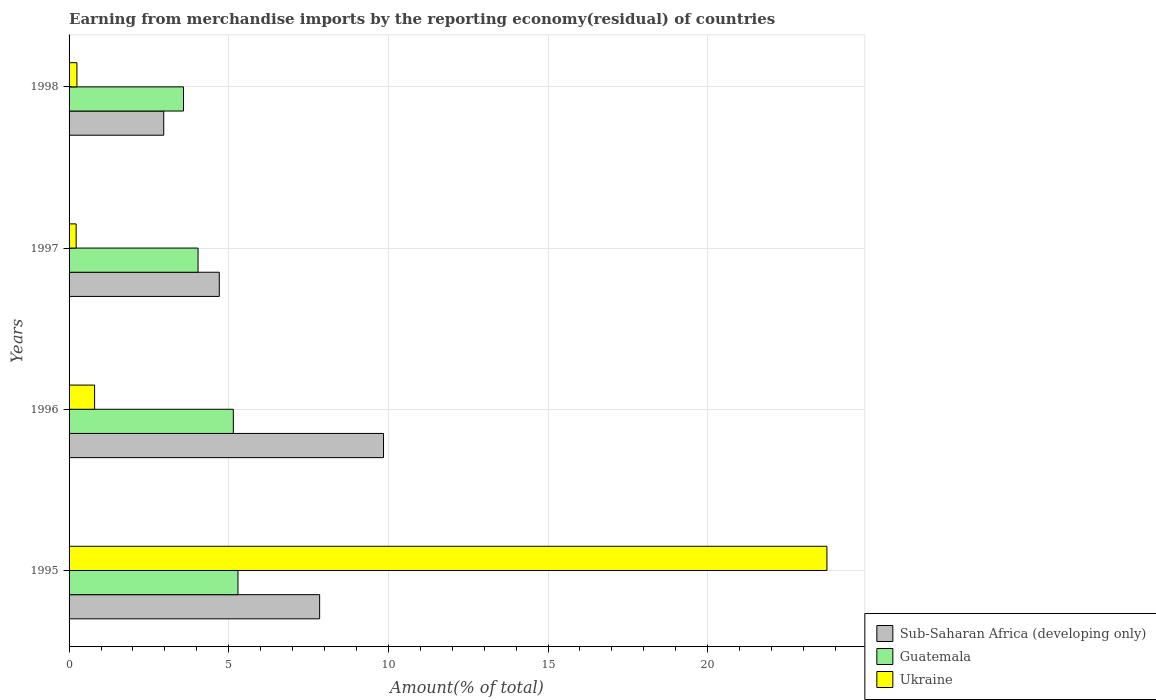How many different coloured bars are there?
Provide a succinct answer. 3. How many groups of bars are there?
Offer a very short reply. 4. How many bars are there on the 3rd tick from the top?
Your answer should be compact. 3. What is the label of the 3rd group of bars from the top?
Your answer should be compact. 1996. In how many cases, is the number of bars for a given year not equal to the number of legend labels?
Provide a succinct answer. 0. What is the percentage of amount earned from merchandise imports in Guatemala in 1995?
Your answer should be compact. 5.29. Across all years, what is the maximum percentage of amount earned from merchandise imports in Guatemala?
Your answer should be very brief. 5.29. Across all years, what is the minimum percentage of amount earned from merchandise imports in Ukraine?
Your response must be concise. 0.22. In which year was the percentage of amount earned from merchandise imports in Sub-Saharan Africa (developing only) maximum?
Offer a terse response. 1996. In which year was the percentage of amount earned from merchandise imports in Sub-Saharan Africa (developing only) minimum?
Offer a terse response. 1998. What is the total percentage of amount earned from merchandise imports in Ukraine in the graph?
Offer a terse response. 25. What is the difference between the percentage of amount earned from merchandise imports in Ukraine in 1996 and that in 1997?
Offer a very short reply. 0.58. What is the difference between the percentage of amount earned from merchandise imports in Sub-Saharan Africa (developing only) in 1996 and the percentage of amount earned from merchandise imports in Ukraine in 1995?
Your response must be concise. -13.89. What is the average percentage of amount earned from merchandise imports in Sub-Saharan Africa (developing only) per year?
Ensure brevity in your answer.  6.34. In the year 1995, what is the difference between the percentage of amount earned from merchandise imports in Ukraine and percentage of amount earned from merchandise imports in Guatemala?
Ensure brevity in your answer.  18.45. What is the ratio of the percentage of amount earned from merchandise imports in Guatemala in 1995 to that in 1996?
Your answer should be very brief. 1.03. Is the difference between the percentage of amount earned from merchandise imports in Ukraine in 1996 and 1998 greater than the difference between the percentage of amount earned from merchandise imports in Guatemala in 1996 and 1998?
Provide a short and direct response. No. What is the difference between the highest and the second highest percentage of amount earned from merchandise imports in Sub-Saharan Africa (developing only)?
Offer a very short reply. 2. What is the difference between the highest and the lowest percentage of amount earned from merchandise imports in Guatemala?
Ensure brevity in your answer.  1.71. In how many years, is the percentage of amount earned from merchandise imports in Sub-Saharan Africa (developing only) greater than the average percentage of amount earned from merchandise imports in Sub-Saharan Africa (developing only) taken over all years?
Offer a very short reply. 2. What does the 2nd bar from the top in 1997 represents?
Provide a succinct answer. Guatemala. What does the 1st bar from the bottom in 1996 represents?
Make the answer very short. Sub-Saharan Africa (developing only). How many bars are there?
Your answer should be compact. 12. Are the values on the major ticks of X-axis written in scientific E-notation?
Your response must be concise. No. How many legend labels are there?
Ensure brevity in your answer.  3. How are the legend labels stacked?
Offer a very short reply. Vertical. What is the title of the graph?
Keep it short and to the point. Earning from merchandise imports by the reporting economy(residual) of countries. What is the label or title of the X-axis?
Provide a short and direct response. Amount(% of total). What is the label or title of the Y-axis?
Provide a short and direct response. Years. What is the Amount(% of total) in Sub-Saharan Africa (developing only) in 1995?
Ensure brevity in your answer.  7.85. What is the Amount(% of total) in Guatemala in 1995?
Your answer should be very brief. 5.29. What is the Amount(% of total) of Ukraine in 1995?
Ensure brevity in your answer.  23.74. What is the Amount(% of total) of Sub-Saharan Africa (developing only) in 1996?
Your answer should be compact. 9.85. What is the Amount(% of total) in Guatemala in 1996?
Your answer should be very brief. 5.14. What is the Amount(% of total) in Ukraine in 1996?
Provide a succinct answer. 0.8. What is the Amount(% of total) of Sub-Saharan Africa (developing only) in 1997?
Provide a succinct answer. 4.7. What is the Amount(% of total) of Guatemala in 1997?
Your answer should be very brief. 4.04. What is the Amount(% of total) of Ukraine in 1997?
Provide a succinct answer. 0.22. What is the Amount(% of total) in Sub-Saharan Africa (developing only) in 1998?
Ensure brevity in your answer.  2.96. What is the Amount(% of total) of Guatemala in 1998?
Give a very brief answer. 3.58. What is the Amount(% of total) in Ukraine in 1998?
Offer a terse response. 0.25. Across all years, what is the maximum Amount(% of total) of Sub-Saharan Africa (developing only)?
Your answer should be compact. 9.85. Across all years, what is the maximum Amount(% of total) of Guatemala?
Provide a succinct answer. 5.29. Across all years, what is the maximum Amount(% of total) of Ukraine?
Offer a terse response. 23.74. Across all years, what is the minimum Amount(% of total) of Sub-Saharan Africa (developing only)?
Offer a terse response. 2.96. Across all years, what is the minimum Amount(% of total) in Guatemala?
Keep it short and to the point. 3.58. Across all years, what is the minimum Amount(% of total) in Ukraine?
Your response must be concise. 0.22. What is the total Amount(% of total) of Sub-Saharan Africa (developing only) in the graph?
Give a very brief answer. 25.37. What is the total Amount(% of total) of Guatemala in the graph?
Offer a very short reply. 18.06. What is the total Amount(% of total) of Ukraine in the graph?
Your response must be concise. 25. What is the difference between the Amount(% of total) of Sub-Saharan Africa (developing only) in 1995 and that in 1996?
Offer a terse response. -2. What is the difference between the Amount(% of total) of Guatemala in 1995 and that in 1996?
Keep it short and to the point. 0.15. What is the difference between the Amount(% of total) in Ukraine in 1995 and that in 1996?
Your answer should be compact. 22.94. What is the difference between the Amount(% of total) of Sub-Saharan Africa (developing only) in 1995 and that in 1997?
Your answer should be very brief. 3.14. What is the difference between the Amount(% of total) of Guatemala in 1995 and that in 1997?
Offer a very short reply. 1.25. What is the difference between the Amount(% of total) of Ukraine in 1995 and that in 1997?
Offer a very short reply. 23.51. What is the difference between the Amount(% of total) of Sub-Saharan Africa (developing only) in 1995 and that in 1998?
Offer a very short reply. 4.88. What is the difference between the Amount(% of total) in Guatemala in 1995 and that in 1998?
Your answer should be very brief. 1.71. What is the difference between the Amount(% of total) in Ukraine in 1995 and that in 1998?
Provide a succinct answer. 23.49. What is the difference between the Amount(% of total) in Sub-Saharan Africa (developing only) in 1996 and that in 1997?
Ensure brevity in your answer.  5.14. What is the difference between the Amount(% of total) in Guatemala in 1996 and that in 1997?
Provide a short and direct response. 1.1. What is the difference between the Amount(% of total) in Ukraine in 1996 and that in 1997?
Your response must be concise. 0.58. What is the difference between the Amount(% of total) in Sub-Saharan Africa (developing only) in 1996 and that in 1998?
Offer a very short reply. 6.88. What is the difference between the Amount(% of total) of Guatemala in 1996 and that in 1998?
Make the answer very short. 1.56. What is the difference between the Amount(% of total) of Ukraine in 1996 and that in 1998?
Make the answer very short. 0.55. What is the difference between the Amount(% of total) of Sub-Saharan Africa (developing only) in 1997 and that in 1998?
Give a very brief answer. 1.74. What is the difference between the Amount(% of total) of Guatemala in 1997 and that in 1998?
Give a very brief answer. 0.46. What is the difference between the Amount(% of total) of Ukraine in 1997 and that in 1998?
Ensure brevity in your answer.  -0.02. What is the difference between the Amount(% of total) in Sub-Saharan Africa (developing only) in 1995 and the Amount(% of total) in Guatemala in 1996?
Keep it short and to the point. 2.7. What is the difference between the Amount(% of total) in Sub-Saharan Africa (developing only) in 1995 and the Amount(% of total) in Ukraine in 1996?
Provide a succinct answer. 7.05. What is the difference between the Amount(% of total) of Guatemala in 1995 and the Amount(% of total) of Ukraine in 1996?
Offer a terse response. 4.49. What is the difference between the Amount(% of total) in Sub-Saharan Africa (developing only) in 1995 and the Amount(% of total) in Guatemala in 1997?
Your response must be concise. 3.81. What is the difference between the Amount(% of total) of Sub-Saharan Africa (developing only) in 1995 and the Amount(% of total) of Ukraine in 1997?
Your answer should be compact. 7.63. What is the difference between the Amount(% of total) of Guatemala in 1995 and the Amount(% of total) of Ukraine in 1997?
Make the answer very short. 5.07. What is the difference between the Amount(% of total) in Sub-Saharan Africa (developing only) in 1995 and the Amount(% of total) in Guatemala in 1998?
Give a very brief answer. 4.26. What is the difference between the Amount(% of total) in Sub-Saharan Africa (developing only) in 1995 and the Amount(% of total) in Ukraine in 1998?
Provide a succinct answer. 7.6. What is the difference between the Amount(% of total) of Guatemala in 1995 and the Amount(% of total) of Ukraine in 1998?
Provide a short and direct response. 5.04. What is the difference between the Amount(% of total) in Sub-Saharan Africa (developing only) in 1996 and the Amount(% of total) in Guatemala in 1997?
Make the answer very short. 5.81. What is the difference between the Amount(% of total) in Sub-Saharan Africa (developing only) in 1996 and the Amount(% of total) in Ukraine in 1997?
Offer a very short reply. 9.63. What is the difference between the Amount(% of total) in Guatemala in 1996 and the Amount(% of total) in Ukraine in 1997?
Provide a succinct answer. 4.92. What is the difference between the Amount(% of total) of Sub-Saharan Africa (developing only) in 1996 and the Amount(% of total) of Guatemala in 1998?
Offer a terse response. 6.26. What is the difference between the Amount(% of total) in Sub-Saharan Africa (developing only) in 1996 and the Amount(% of total) in Ukraine in 1998?
Give a very brief answer. 9.6. What is the difference between the Amount(% of total) of Guatemala in 1996 and the Amount(% of total) of Ukraine in 1998?
Provide a succinct answer. 4.9. What is the difference between the Amount(% of total) in Sub-Saharan Africa (developing only) in 1997 and the Amount(% of total) in Guatemala in 1998?
Offer a terse response. 1.12. What is the difference between the Amount(% of total) of Sub-Saharan Africa (developing only) in 1997 and the Amount(% of total) of Ukraine in 1998?
Provide a short and direct response. 4.46. What is the difference between the Amount(% of total) of Guatemala in 1997 and the Amount(% of total) of Ukraine in 1998?
Offer a terse response. 3.79. What is the average Amount(% of total) in Sub-Saharan Africa (developing only) per year?
Ensure brevity in your answer.  6.34. What is the average Amount(% of total) of Guatemala per year?
Give a very brief answer. 4.51. What is the average Amount(% of total) of Ukraine per year?
Ensure brevity in your answer.  6.25. In the year 1995, what is the difference between the Amount(% of total) of Sub-Saharan Africa (developing only) and Amount(% of total) of Guatemala?
Offer a very short reply. 2.56. In the year 1995, what is the difference between the Amount(% of total) in Sub-Saharan Africa (developing only) and Amount(% of total) in Ukraine?
Provide a short and direct response. -15.89. In the year 1995, what is the difference between the Amount(% of total) of Guatemala and Amount(% of total) of Ukraine?
Your response must be concise. -18.45. In the year 1996, what is the difference between the Amount(% of total) of Sub-Saharan Africa (developing only) and Amount(% of total) of Guatemala?
Provide a short and direct response. 4.7. In the year 1996, what is the difference between the Amount(% of total) of Sub-Saharan Africa (developing only) and Amount(% of total) of Ukraine?
Your response must be concise. 9.05. In the year 1996, what is the difference between the Amount(% of total) of Guatemala and Amount(% of total) of Ukraine?
Provide a succinct answer. 4.34. In the year 1997, what is the difference between the Amount(% of total) in Sub-Saharan Africa (developing only) and Amount(% of total) in Guatemala?
Provide a succinct answer. 0.66. In the year 1997, what is the difference between the Amount(% of total) in Sub-Saharan Africa (developing only) and Amount(% of total) in Ukraine?
Keep it short and to the point. 4.48. In the year 1997, what is the difference between the Amount(% of total) of Guatemala and Amount(% of total) of Ukraine?
Offer a very short reply. 3.82. In the year 1998, what is the difference between the Amount(% of total) in Sub-Saharan Africa (developing only) and Amount(% of total) in Guatemala?
Make the answer very short. -0.62. In the year 1998, what is the difference between the Amount(% of total) of Sub-Saharan Africa (developing only) and Amount(% of total) of Ukraine?
Your answer should be compact. 2.72. In the year 1998, what is the difference between the Amount(% of total) of Guatemala and Amount(% of total) of Ukraine?
Your answer should be compact. 3.34. What is the ratio of the Amount(% of total) of Sub-Saharan Africa (developing only) in 1995 to that in 1996?
Make the answer very short. 0.8. What is the ratio of the Amount(% of total) in Guatemala in 1995 to that in 1996?
Provide a short and direct response. 1.03. What is the ratio of the Amount(% of total) in Ukraine in 1995 to that in 1996?
Give a very brief answer. 29.69. What is the ratio of the Amount(% of total) in Sub-Saharan Africa (developing only) in 1995 to that in 1997?
Your answer should be very brief. 1.67. What is the ratio of the Amount(% of total) of Guatemala in 1995 to that in 1997?
Your answer should be compact. 1.31. What is the ratio of the Amount(% of total) in Ukraine in 1995 to that in 1997?
Offer a very short reply. 107.18. What is the ratio of the Amount(% of total) of Sub-Saharan Africa (developing only) in 1995 to that in 1998?
Provide a short and direct response. 2.65. What is the ratio of the Amount(% of total) in Guatemala in 1995 to that in 1998?
Provide a succinct answer. 1.48. What is the ratio of the Amount(% of total) in Ukraine in 1995 to that in 1998?
Make the answer very short. 96.49. What is the ratio of the Amount(% of total) in Sub-Saharan Africa (developing only) in 1996 to that in 1997?
Ensure brevity in your answer.  2.09. What is the ratio of the Amount(% of total) of Guatemala in 1996 to that in 1997?
Keep it short and to the point. 1.27. What is the ratio of the Amount(% of total) in Ukraine in 1996 to that in 1997?
Your answer should be compact. 3.61. What is the ratio of the Amount(% of total) in Sub-Saharan Africa (developing only) in 1996 to that in 1998?
Keep it short and to the point. 3.32. What is the ratio of the Amount(% of total) in Guatemala in 1996 to that in 1998?
Provide a succinct answer. 1.44. What is the ratio of the Amount(% of total) of Ukraine in 1996 to that in 1998?
Provide a succinct answer. 3.25. What is the ratio of the Amount(% of total) of Sub-Saharan Africa (developing only) in 1997 to that in 1998?
Offer a very short reply. 1.59. What is the ratio of the Amount(% of total) of Guatemala in 1997 to that in 1998?
Keep it short and to the point. 1.13. What is the ratio of the Amount(% of total) of Ukraine in 1997 to that in 1998?
Keep it short and to the point. 0.9. What is the difference between the highest and the second highest Amount(% of total) of Sub-Saharan Africa (developing only)?
Your answer should be compact. 2. What is the difference between the highest and the second highest Amount(% of total) in Guatemala?
Your response must be concise. 0.15. What is the difference between the highest and the second highest Amount(% of total) of Ukraine?
Provide a short and direct response. 22.94. What is the difference between the highest and the lowest Amount(% of total) of Sub-Saharan Africa (developing only)?
Your answer should be very brief. 6.88. What is the difference between the highest and the lowest Amount(% of total) of Guatemala?
Give a very brief answer. 1.71. What is the difference between the highest and the lowest Amount(% of total) in Ukraine?
Provide a short and direct response. 23.51. 